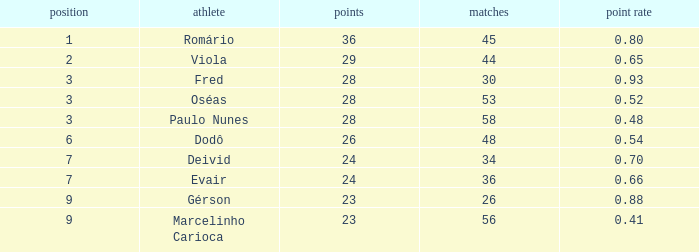How many games possess 23 goals and a ranking above 9? 0.0. 